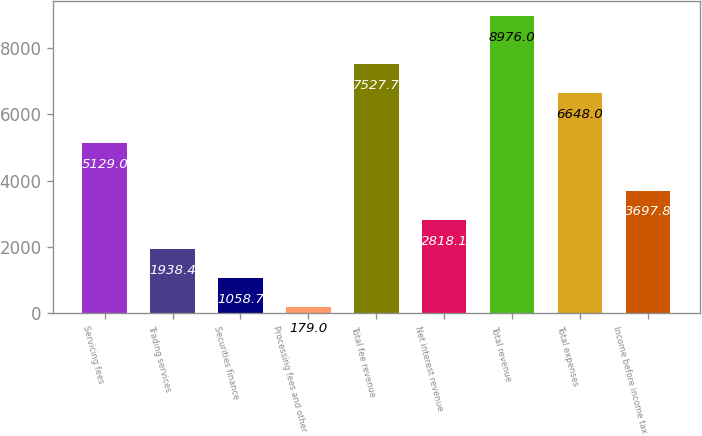Convert chart to OTSL. <chart><loc_0><loc_0><loc_500><loc_500><bar_chart><fcel>Servicing fees<fcel>Trading services<fcel>Securities finance<fcel>Processing fees and other<fcel>Total fee revenue<fcel>Net interest revenue<fcel>Total revenue<fcel>Total expenses<fcel>Income before income tax<nl><fcel>5129<fcel>1938.4<fcel>1058.7<fcel>179<fcel>7527.7<fcel>2818.1<fcel>8976<fcel>6648<fcel>3697.8<nl></chart> 